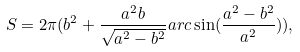Convert formula to latex. <formula><loc_0><loc_0><loc_500><loc_500>S = 2 \pi ( b ^ { 2 } + \frac { a ^ { 2 } b } { \sqrt { a ^ { 2 } - b ^ { 2 } } } a r c \sin ( \frac { a ^ { 2 } - b ^ { 2 } } { a ^ { 2 } } ) ) ,</formula> 